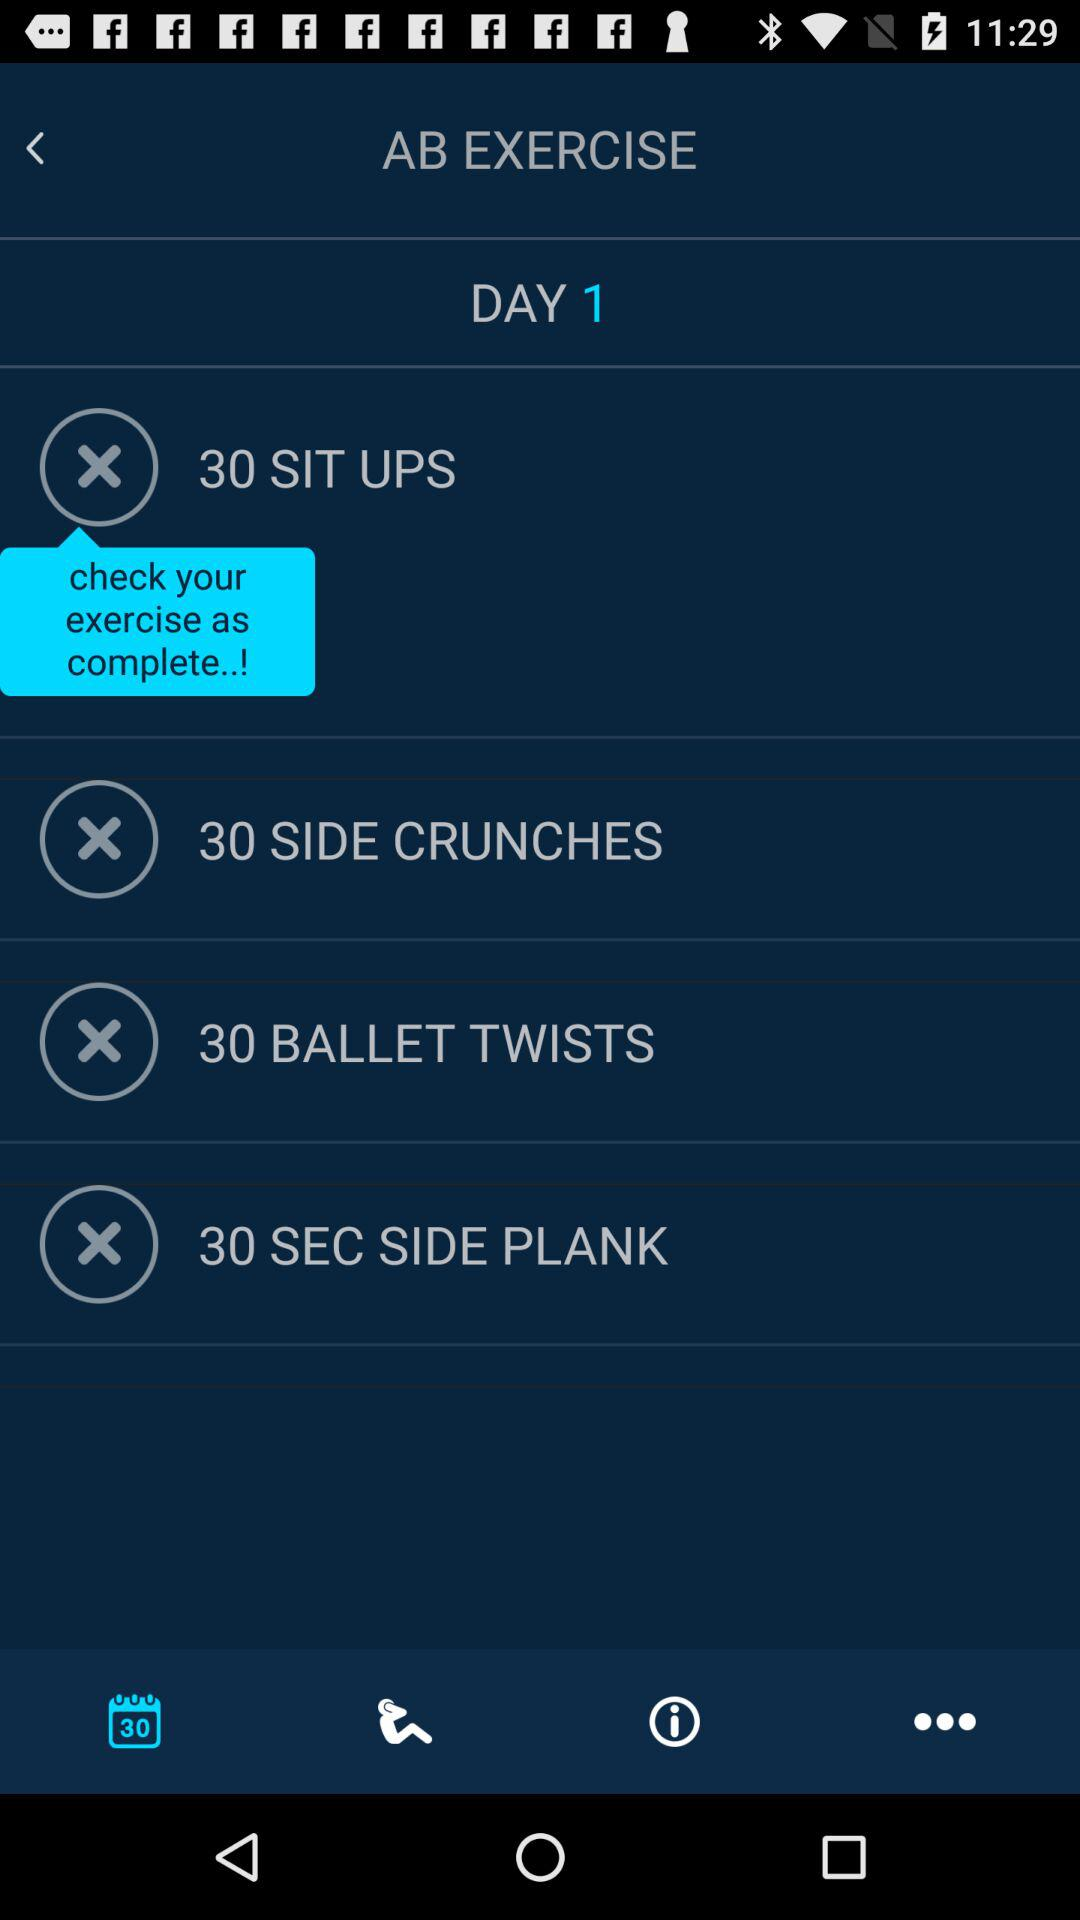How many exercises are there in total?
Answer the question using a single word or phrase. 4 